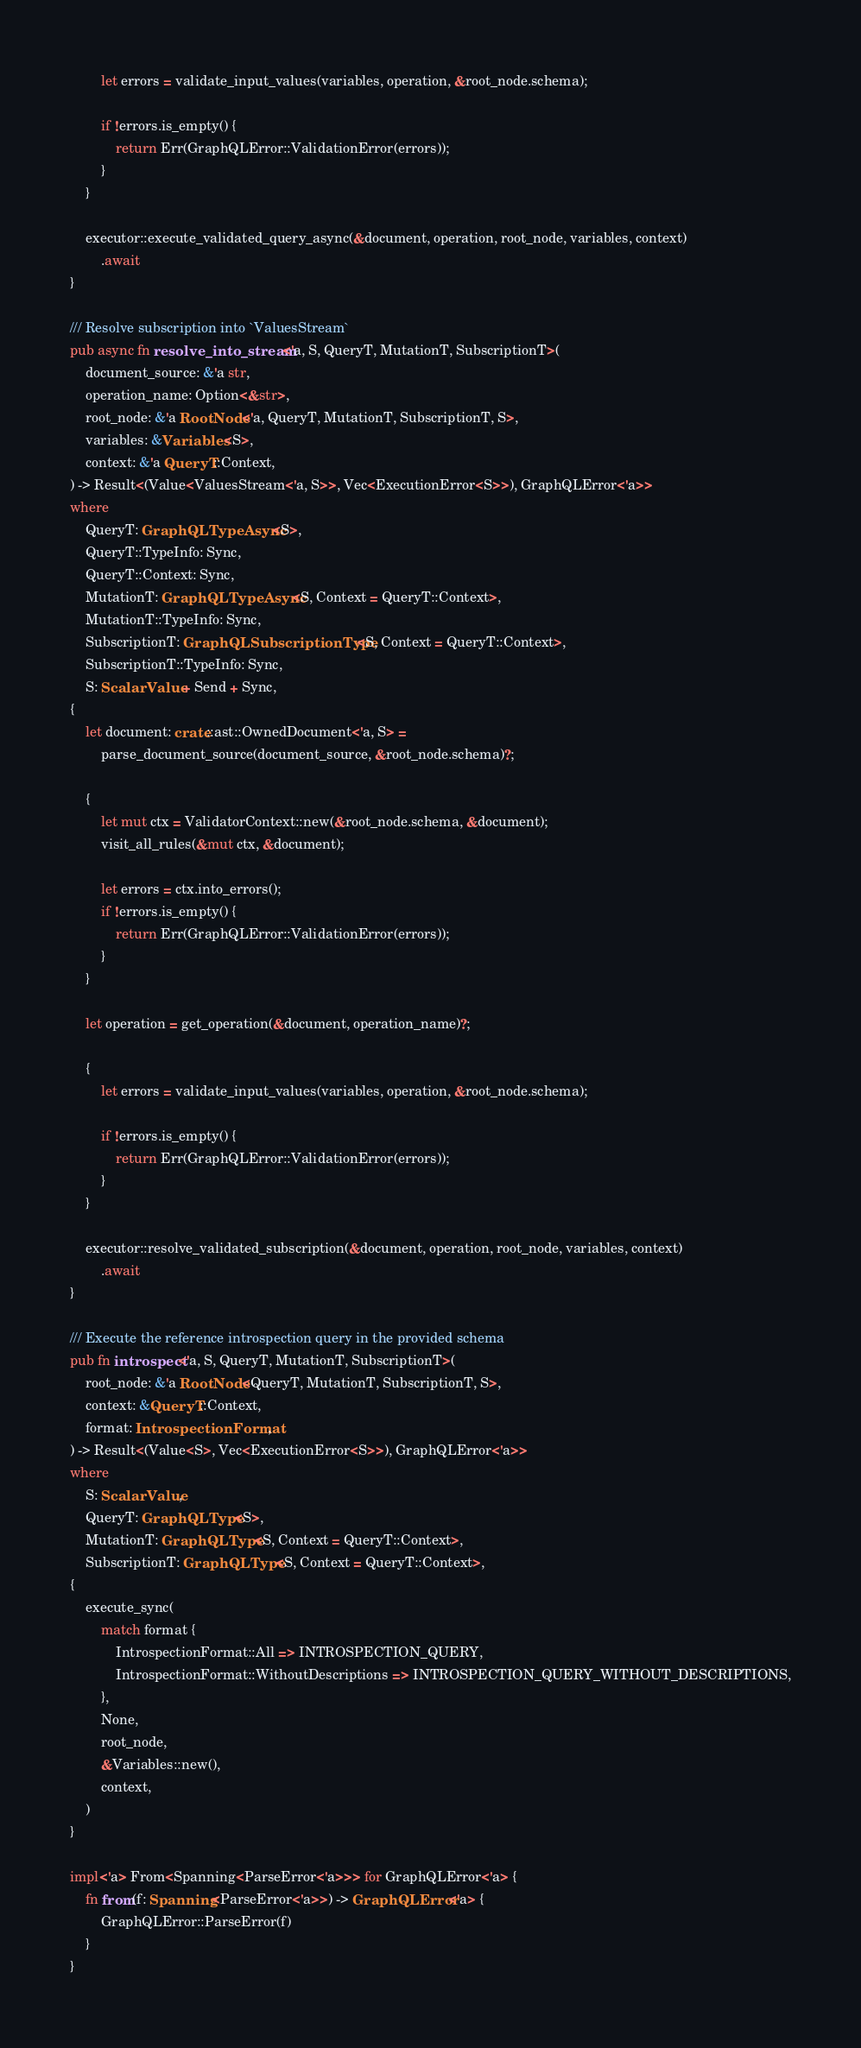Convert code to text. <code><loc_0><loc_0><loc_500><loc_500><_Rust_>        let errors = validate_input_values(variables, operation, &root_node.schema);

        if !errors.is_empty() {
            return Err(GraphQLError::ValidationError(errors));
        }
    }

    executor::execute_validated_query_async(&document, operation, root_node, variables, context)
        .await
}

/// Resolve subscription into `ValuesStream`
pub async fn resolve_into_stream<'a, S, QueryT, MutationT, SubscriptionT>(
    document_source: &'a str,
    operation_name: Option<&str>,
    root_node: &'a RootNode<'a, QueryT, MutationT, SubscriptionT, S>,
    variables: &Variables<S>,
    context: &'a QueryT::Context,
) -> Result<(Value<ValuesStream<'a, S>>, Vec<ExecutionError<S>>), GraphQLError<'a>>
where
    QueryT: GraphQLTypeAsync<S>,
    QueryT::TypeInfo: Sync,
    QueryT::Context: Sync,
    MutationT: GraphQLTypeAsync<S, Context = QueryT::Context>,
    MutationT::TypeInfo: Sync,
    SubscriptionT: GraphQLSubscriptionType<S, Context = QueryT::Context>,
    SubscriptionT::TypeInfo: Sync,
    S: ScalarValue + Send + Sync,
{
    let document: crate::ast::OwnedDocument<'a, S> =
        parse_document_source(document_source, &root_node.schema)?;

    {
        let mut ctx = ValidatorContext::new(&root_node.schema, &document);
        visit_all_rules(&mut ctx, &document);

        let errors = ctx.into_errors();
        if !errors.is_empty() {
            return Err(GraphQLError::ValidationError(errors));
        }
    }

    let operation = get_operation(&document, operation_name)?;

    {
        let errors = validate_input_values(variables, operation, &root_node.schema);

        if !errors.is_empty() {
            return Err(GraphQLError::ValidationError(errors));
        }
    }

    executor::resolve_validated_subscription(&document, operation, root_node, variables, context)
        .await
}

/// Execute the reference introspection query in the provided schema
pub fn introspect<'a, S, QueryT, MutationT, SubscriptionT>(
    root_node: &'a RootNode<QueryT, MutationT, SubscriptionT, S>,
    context: &QueryT::Context,
    format: IntrospectionFormat,
) -> Result<(Value<S>, Vec<ExecutionError<S>>), GraphQLError<'a>>
where
    S: ScalarValue,
    QueryT: GraphQLType<S>,
    MutationT: GraphQLType<S, Context = QueryT::Context>,
    SubscriptionT: GraphQLType<S, Context = QueryT::Context>,
{
    execute_sync(
        match format {
            IntrospectionFormat::All => INTROSPECTION_QUERY,
            IntrospectionFormat::WithoutDescriptions => INTROSPECTION_QUERY_WITHOUT_DESCRIPTIONS,
        },
        None,
        root_node,
        &Variables::new(),
        context,
    )
}

impl<'a> From<Spanning<ParseError<'a>>> for GraphQLError<'a> {
    fn from(f: Spanning<ParseError<'a>>) -> GraphQLError<'a> {
        GraphQLError::ParseError(f)
    }
}
</code> 